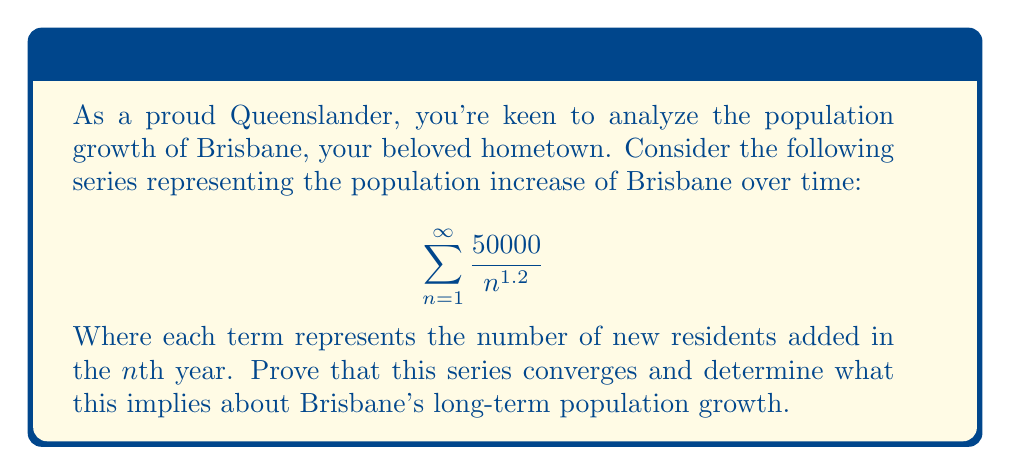Solve this math problem. Let's approach this step-by-step:

1) First, we need to recognize that this is a p-series of the form $$\sum_{n=1}^{\infty} \frac{1}{n^p}$$ where $p = 1.2$ and there's a constant factor of 50000.

2) For p-series, we know that:
   - If $p > 1$, the series converges
   - If $p \leq 1$, the series diverges

3) In our case, $p = 1.2 > 1$, so this series converges.

4) To prove this rigorously, we can use the integral test:

   Let $f(x) = \frac{50000}{x^{1.2}}$. This function is positive and decreasing for $x \geq 1$.

5) We evaluate the improper integral:

   $$\int_{1}^{\infty} \frac{50000}{x^{1.2}} dx = \lim_{b \to \infty} 50000 \left[\frac{x^{-0.2}}{-0.2}\right]_{1}^{b}$$
   
   $$= \lim_{b \to \infty} 50000 \left(\frac{1}{0.2} - \frac{b^{-0.2}}{0.2}\right)$$
   
   $$= \frac{50000}{0.2} - 0 = 250000$$

6) Since this improper integral converges to a finite value, by the integral test, our original series also converges.

7) The convergence of this series implies that the total population increase of Brisbane over an infinite time period is finite. In other words, the population will approach a maximum limit and won't grow indefinitely.
Answer: The series converges, implying Brisbane's population growth is bounded. 